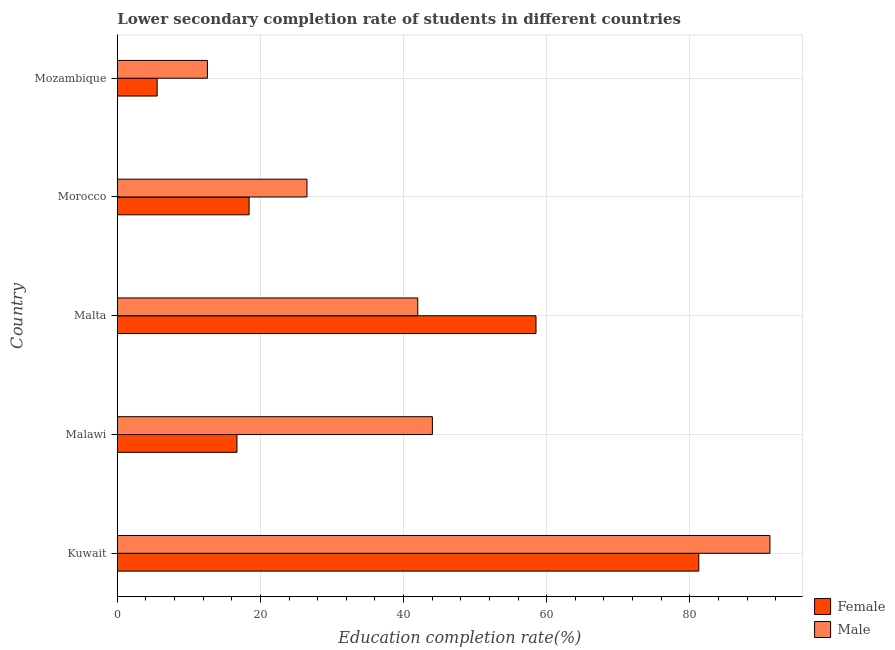Are the number of bars per tick equal to the number of legend labels?
Ensure brevity in your answer.  Yes. Are the number of bars on each tick of the Y-axis equal?
Your answer should be very brief. Yes. How many bars are there on the 4th tick from the top?
Ensure brevity in your answer.  2. What is the label of the 1st group of bars from the top?
Ensure brevity in your answer.  Mozambique. In how many cases, is the number of bars for a given country not equal to the number of legend labels?
Your answer should be very brief. 0. What is the education completion rate of female students in Mozambique?
Provide a succinct answer. 5.57. Across all countries, what is the maximum education completion rate of female students?
Ensure brevity in your answer.  81.26. Across all countries, what is the minimum education completion rate of male students?
Your answer should be very brief. 12.59. In which country was the education completion rate of female students maximum?
Ensure brevity in your answer.  Kuwait. In which country was the education completion rate of female students minimum?
Your answer should be compact. Mozambique. What is the total education completion rate of female students in the graph?
Your answer should be very brief. 180.49. What is the difference between the education completion rate of male students in Malawi and that in Morocco?
Offer a very short reply. 17.53. What is the difference between the education completion rate of female students in Malta and the education completion rate of male students in Malawi?
Ensure brevity in your answer.  14.48. What is the average education completion rate of female students per country?
Offer a terse response. 36.1. What is the difference between the education completion rate of male students and education completion rate of female students in Malawi?
Provide a short and direct response. 27.31. In how many countries, is the education completion rate of female students greater than 12 %?
Offer a terse response. 4. What is the ratio of the education completion rate of female students in Malta to that in Morocco?
Ensure brevity in your answer.  3.18. What is the difference between the highest and the second highest education completion rate of male students?
Make the answer very short. 47.17. What is the difference between the highest and the lowest education completion rate of female students?
Offer a terse response. 75.69. In how many countries, is the education completion rate of female students greater than the average education completion rate of female students taken over all countries?
Your answer should be very brief. 2. What does the 1st bar from the top in Morocco represents?
Give a very brief answer. Male. What does the 1st bar from the bottom in Kuwait represents?
Ensure brevity in your answer.  Female. What is the difference between two consecutive major ticks on the X-axis?
Offer a very short reply. 20. Does the graph contain grids?
Offer a terse response. Yes. What is the title of the graph?
Provide a succinct answer. Lower secondary completion rate of students in different countries. What is the label or title of the X-axis?
Ensure brevity in your answer.  Education completion rate(%). What is the label or title of the Y-axis?
Ensure brevity in your answer.  Country. What is the Education completion rate(%) of Female in Kuwait?
Keep it short and to the point. 81.26. What is the Education completion rate(%) in Male in Kuwait?
Your response must be concise. 91.21. What is the Education completion rate(%) in Female in Malawi?
Provide a short and direct response. 16.72. What is the Education completion rate(%) in Male in Malawi?
Ensure brevity in your answer.  44.03. What is the Education completion rate(%) in Female in Malta?
Provide a short and direct response. 58.51. What is the Education completion rate(%) of Male in Malta?
Offer a terse response. 41.99. What is the Education completion rate(%) in Female in Morocco?
Provide a short and direct response. 18.42. What is the Education completion rate(%) of Male in Morocco?
Make the answer very short. 26.51. What is the Education completion rate(%) in Female in Mozambique?
Offer a very short reply. 5.57. What is the Education completion rate(%) in Male in Mozambique?
Your response must be concise. 12.59. Across all countries, what is the maximum Education completion rate(%) of Female?
Your answer should be compact. 81.26. Across all countries, what is the maximum Education completion rate(%) of Male?
Give a very brief answer. 91.21. Across all countries, what is the minimum Education completion rate(%) of Female?
Give a very brief answer. 5.57. Across all countries, what is the minimum Education completion rate(%) of Male?
Give a very brief answer. 12.59. What is the total Education completion rate(%) of Female in the graph?
Give a very brief answer. 180.49. What is the total Education completion rate(%) of Male in the graph?
Give a very brief answer. 216.33. What is the difference between the Education completion rate(%) of Female in Kuwait and that in Malawi?
Your answer should be compact. 64.54. What is the difference between the Education completion rate(%) of Male in Kuwait and that in Malawi?
Make the answer very short. 47.17. What is the difference between the Education completion rate(%) of Female in Kuwait and that in Malta?
Ensure brevity in your answer.  22.75. What is the difference between the Education completion rate(%) of Male in Kuwait and that in Malta?
Make the answer very short. 49.21. What is the difference between the Education completion rate(%) of Female in Kuwait and that in Morocco?
Keep it short and to the point. 62.84. What is the difference between the Education completion rate(%) of Male in Kuwait and that in Morocco?
Offer a very short reply. 64.7. What is the difference between the Education completion rate(%) in Female in Kuwait and that in Mozambique?
Ensure brevity in your answer.  75.69. What is the difference between the Education completion rate(%) of Male in Kuwait and that in Mozambique?
Your answer should be very brief. 78.61. What is the difference between the Education completion rate(%) in Female in Malawi and that in Malta?
Ensure brevity in your answer.  -41.79. What is the difference between the Education completion rate(%) in Male in Malawi and that in Malta?
Keep it short and to the point. 2.04. What is the difference between the Education completion rate(%) of Female in Malawi and that in Morocco?
Provide a succinct answer. -1.7. What is the difference between the Education completion rate(%) in Male in Malawi and that in Morocco?
Provide a short and direct response. 17.53. What is the difference between the Education completion rate(%) in Female in Malawi and that in Mozambique?
Provide a short and direct response. 11.15. What is the difference between the Education completion rate(%) in Male in Malawi and that in Mozambique?
Make the answer very short. 31.44. What is the difference between the Education completion rate(%) of Female in Malta and that in Morocco?
Keep it short and to the point. 40.09. What is the difference between the Education completion rate(%) in Male in Malta and that in Morocco?
Your answer should be very brief. 15.49. What is the difference between the Education completion rate(%) of Female in Malta and that in Mozambique?
Keep it short and to the point. 52.94. What is the difference between the Education completion rate(%) of Male in Malta and that in Mozambique?
Ensure brevity in your answer.  29.4. What is the difference between the Education completion rate(%) in Female in Morocco and that in Mozambique?
Give a very brief answer. 12.85. What is the difference between the Education completion rate(%) in Male in Morocco and that in Mozambique?
Keep it short and to the point. 13.91. What is the difference between the Education completion rate(%) of Female in Kuwait and the Education completion rate(%) of Male in Malawi?
Keep it short and to the point. 37.23. What is the difference between the Education completion rate(%) in Female in Kuwait and the Education completion rate(%) in Male in Malta?
Make the answer very short. 39.27. What is the difference between the Education completion rate(%) of Female in Kuwait and the Education completion rate(%) of Male in Morocco?
Give a very brief answer. 54.76. What is the difference between the Education completion rate(%) in Female in Kuwait and the Education completion rate(%) in Male in Mozambique?
Offer a very short reply. 68.67. What is the difference between the Education completion rate(%) in Female in Malawi and the Education completion rate(%) in Male in Malta?
Ensure brevity in your answer.  -25.27. What is the difference between the Education completion rate(%) of Female in Malawi and the Education completion rate(%) of Male in Morocco?
Provide a succinct answer. -9.78. What is the difference between the Education completion rate(%) of Female in Malawi and the Education completion rate(%) of Male in Mozambique?
Provide a short and direct response. 4.13. What is the difference between the Education completion rate(%) of Female in Malta and the Education completion rate(%) of Male in Morocco?
Offer a terse response. 32.01. What is the difference between the Education completion rate(%) in Female in Malta and the Education completion rate(%) in Male in Mozambique?
Your answer should be compact. 45.92. What is the difference between the Education completion rate(%) in Female in Morocco and the Education completion rate(%) in Male in Mozambique?
Offer a very short reply. 5.83. What is the average Education completion rate(%) of Female per country?
Provide a short and direct response. 36.1. What is the average Education completion rate(%) in Male per country?
Your response must be concise. 43.27. What is the difference between the Education completion rate(%) in Female and Education completion rate(%) in Male in Kuwait?
Provide a succinct answer. -9.94. What is the difference between the Education completion rate(%) in Female and Education completion rate(%) in Male in Malawi?
Your answer should be very brief. -27.31. What is the difference between the Education completion rate(%) of Female and Education completion rate(%) of Male in Malta?
Offer a very short reply. 16.52. What is the difference between the Education completion rate(%) of Female and Education completion rate(%) of Male in Morocco?
Give a very brief answer. -8.09. What is the difference between the Education completion rate(%) in Female and Education completion rate(%) in Male in Mozambique?
Your answer should be compact. -7.02. What is the ratio of the Education completion rate(%) in Female in Kuwait to that in Malawi?
Your response must be concise. 4.86. What is the ratio of the Education completion rate(%) in Male in Kuwait to that in Malawi?
Offer a terse response. 2.07. What is the ratio of the Education completion rate(%) in Female in Kuwait to that in Malta?
Keep it short and to the point. 1.39. What is the ratio of the Education completion rate(%) in Male in Kuwait to that in Malta?
Your response must be concise. 2.17. What is the ratio of the Education completion rate(%) in Female in Kuwait to that in Morocco?
Make the answer very short. 4.41. What is the ratio of the Education completion rate(%) of Male in Kuwait to that in Morocco?
Your answer should be very brief. 3.44. What is the ratio of the Education completion rate(%) of Female in Kuwait to that in Mozambique?
Ensure brevity in your answer.  14.58. What is the ratio of the Education completion rate(%) in Male in Kuwait to that in Mozambique?
Give a very brief answer. 7.24. What is the ratio of the Education completion rate(%) of Female in Malawi to that in Malta?
Your answer should be very brief. 0.29. What is the ratio of the Education completion rate(%) of Male in Malawi to that in Malta?
Offer a very short reply. 1.05. What is the ratio of the Education completion rate(%) in Female in Malawi to that in Morocco?
Make the answer very short. 0.91. What is the ratio of the Education completion rate(%) of Male in Malawi to that in Morocco?
Offer a very short reply. 1.66. What is the ratio of the Education completion rate(%) in Female in Malawi to that in Mozambique?
Keep it short and to the point. 3. What is the ratio of the Education completion rate(%) of Male in Malawi to that in Mozambique?
Your response must be concise. 3.5. What is the ratio of the Education completion rate(%) of Female in Malta to that in Morocco?
Ensure brevity in your answer.  3.18. What is the ratio of the Education completion rate(%) of Male in Malta to that in Morocco?
Give a very brief answer. 1.58. What is the ratio of the Education completion rate(%) of Female in Malta to that in Mozambique?
Keep it short and to the point. 10.5. What is the ratio of the Education completion rate(%) in Male in Malta to that in Mozambique?
Offer a very short reply. 3.33. What is the ratio of the Education completion rate(%) of Female in Morocco to that in Mozambique?
Make the answer very short. 3.31. What is the ratio of the Education completion rate(%) in Male in Morocco to that in Mozambique?
Your answer should be compact. 2.1. What is the difference between the highest and the second highest Education completion rate(%) of Female?
Keep it short and to the point. 22.75. What is the difference between the highest and the second highest Education completion rate(%) in Male?
Your answer should be very brief. 47.17. What is the difference between the highest and the lowest Education completion rate(%) in Female?
Make the answer very short. 75.69. What is the difference between the highest and the lowest Education completion rate(%) in Male?
Offer a terse response. 78.61. 